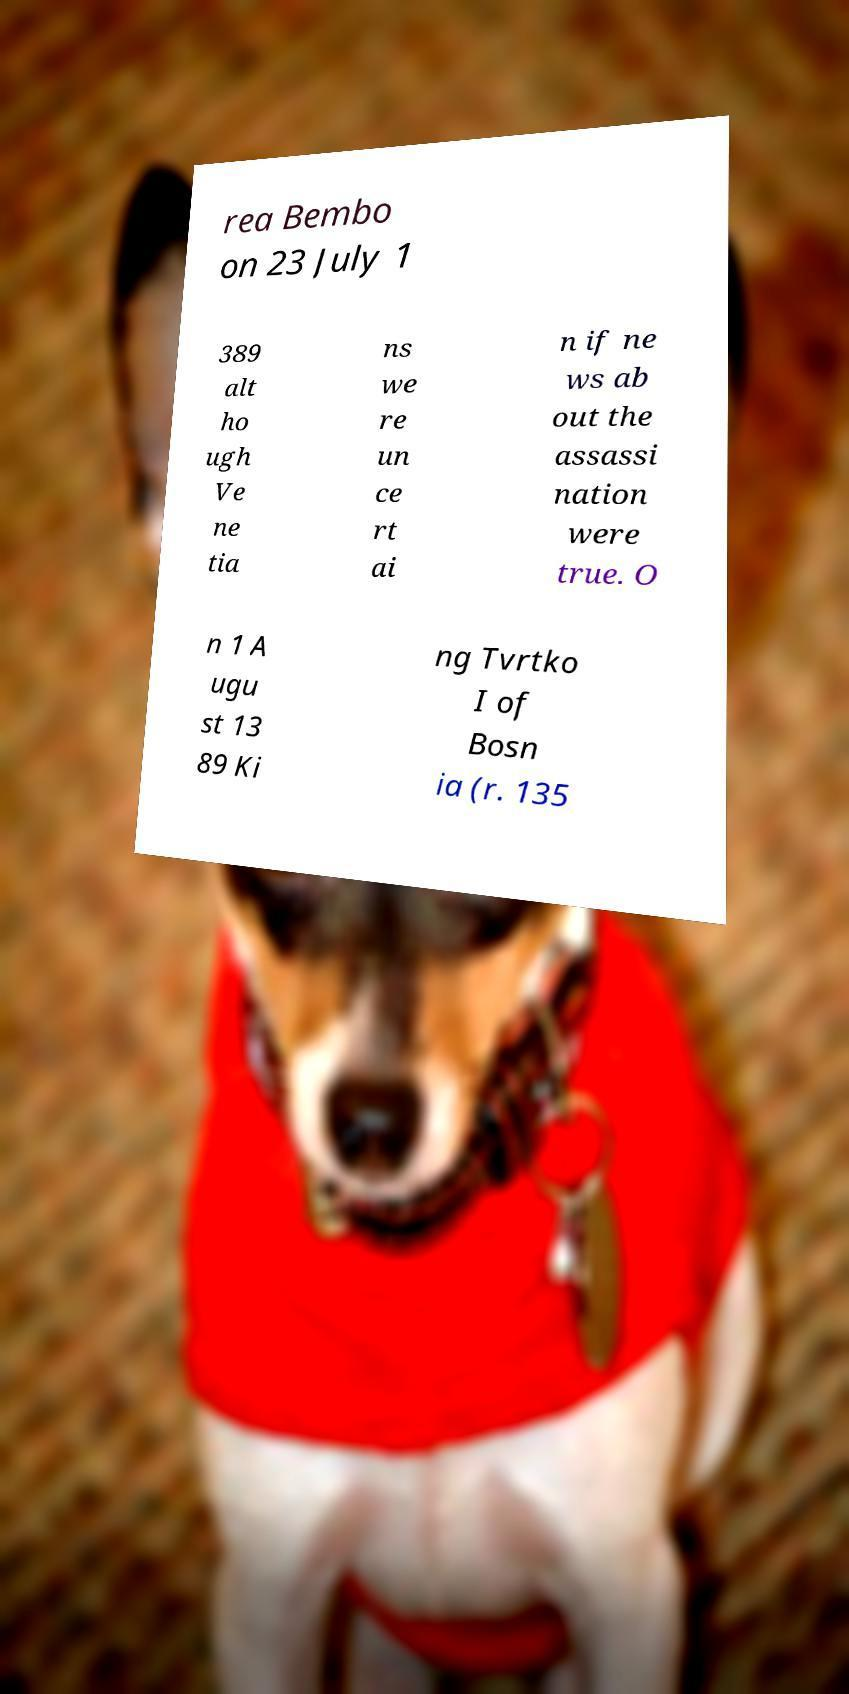Could you assist in decoding the text presented in this image and type it out clearly? rea Bembo on 23 July 1 389 alt ho ugh Ve ne tia ns we re un ce rt ai n if ne ws ab out the assassi nation were true. O n 1 A ugu st 13 89 Ki ng Tvrtko I of Bosn ia (r. 135 